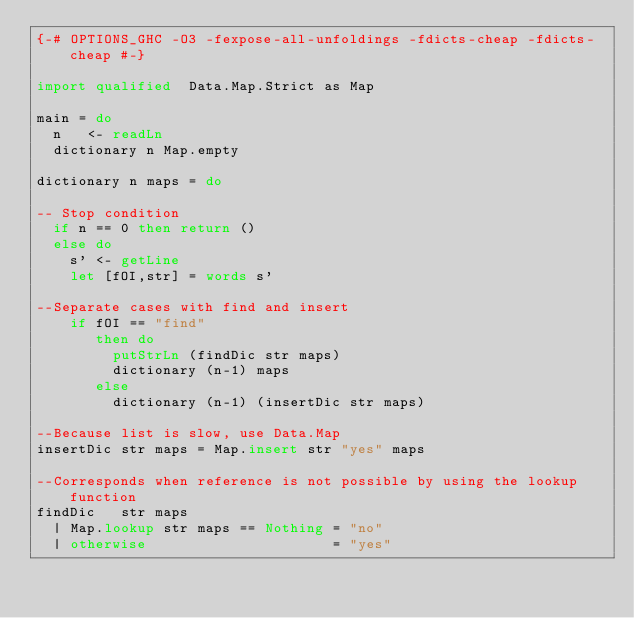<code> <loc_0><loc_0><loc_500><loc_500><_Haskell_>{-# OPTIONS_GHC -O3 -fexpose-all-unfoldings -fdicts-cheap -fdicts-cheap #-}

import qualified  Data.Map.Strict as Map

main = do
  n   <- readLn
  dictionary n Map.empty

dictionary n maps = do

-- Stop condition
  if n == 0 then return ()
  else do
    s' <- getLine
    let [fOI,str] = words s'

--Separate cases with find and insert
    if fOI == "find"
       then do
         putStrLn (findDic str maps)
         dictionary (n-1) maps
       else
         dictionary (n-1) (insertDic str maps)

--Because list is slow, use Data.Map
insertDic str maps = Map.insert str "yes" maps

--Corresponds when reference is not possible by using the lookup function
findDic   str maps
  | Map.lookup str maps == Nothing = "no"
  | otherwise                      = "yes"</code> 